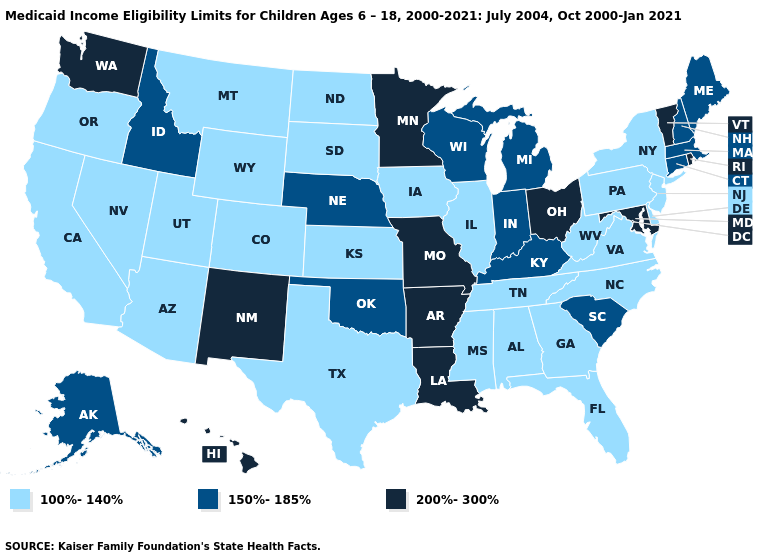Does the map have missing data?
Quick response, please. No. What is the lowest value in the West?
Quick response, please. 100%-140%. Name the states that have a value in the range 100%-140%?
Quick response, please. Alabama, Arizona, California, Colorado, Delaware, Florida, Georgia, Illinois, Iowa, Kansas, Mississippi, Montana, Nevada, New Jersey, New York, North Carolina, North Dakota, Oregon, Pennsylvania, South Dakota, Tennessee, Texas, Utah, Virginia, West Virginia, Wyoming. Does Alabama have the lowest value in the USA?
Keep it brief. Yes. Does Mississippi have the lowest value in the USA?
Keep it brief. Yes. Which states hav the highest value in the Northeast?
Short answer required. Rhode Island, Vermont. Which states have the lowest value in the USA?
Answer briefly. Alabama, Arizona, California, Colorado, Delaware, Florida, Georgia, Illinois, Iowa, Kansas, Mississippi, Montana, Nevada, New Jersey, New York, North Carolina, North Dakota, Oregon, Pennsylvania, South Dakota, Tennessee, Texas, Utah, Virginia, West Virginia, Wyoming. Name the states that have a value in the range 150%-185%?
Short answer required. Alaska, Connecticut, Idaho, Indiana, Kentucky, Maine, Massachusetts, Michigan, Nebraska, New Hampshire, Oklahoma, South Carolina, Wisconsin. Does Wyoming have a lower value than Idaho?
Short answer required. Yes. Among the states that border North Dakota , which have the highest value?
Short answer required. Minnesota. Is the legend a continuous bar?
Concise answer only. No. Name the states that have a value in the range 200%-300%?
Answer briefly. Arkansas, Hawaii, Louisiana, Maryland, Minnesota, Missouri, New Mexico, Ohio, Rhode Island, Vermont, Washington. Is the legend a continuous bar?
Be succinct. No. Does Iowa have the same value as Alabama?
Keep it brief. Yes. Name the states that have a value in the range 150%-185%?
Concise answer only. Alaska, Connecticut, Idaho, Indiana, Kentucky, Maine, Massachusetts, Michigan, Nebraska, New Hampshire, Oklahoma, South Carolina, Wisconsin. 